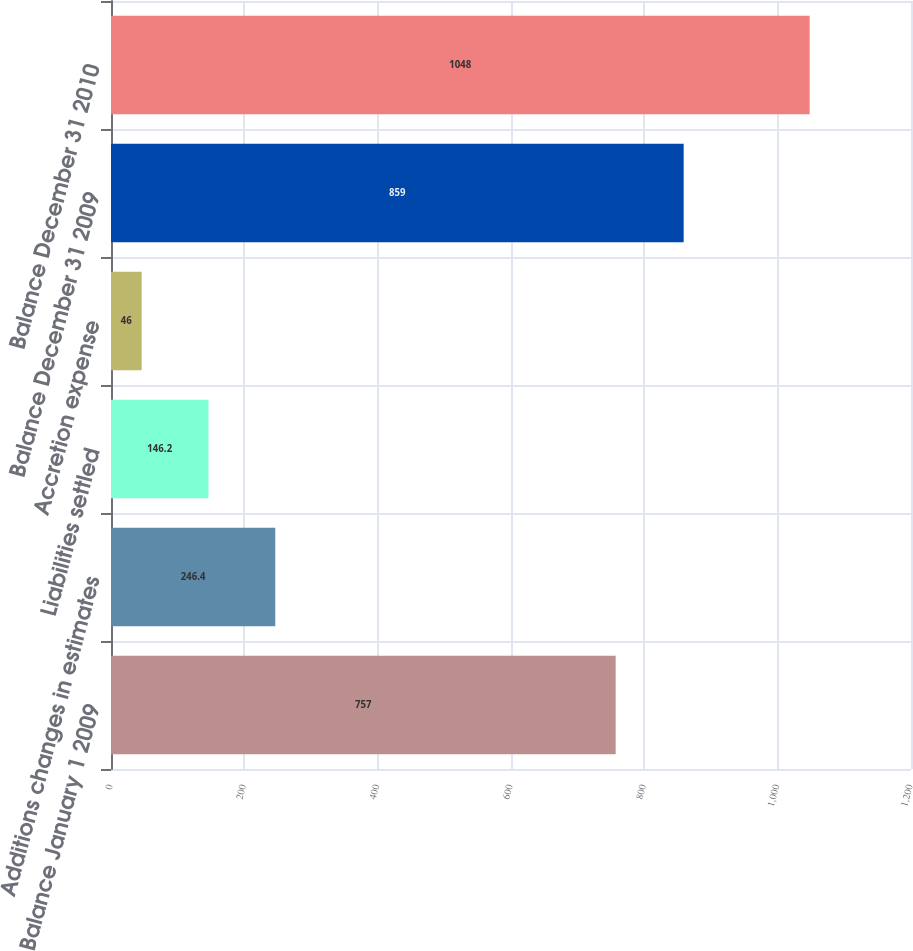<chart> <loc_0><loc_0><loc_500><loc_500><bar_chart><fcel>Balance January 1 2009<fcel>Additions changes in estimates<fcel>Liabilities settled<fcel>Accretion expense<fcel>Balance December 31 2009<fcel>Balance December 31 2010<nl><fcel>757<fcel>246.4<fcel>146.2<fcel>46<fcel>859<fcel>1048<nl></chart> 